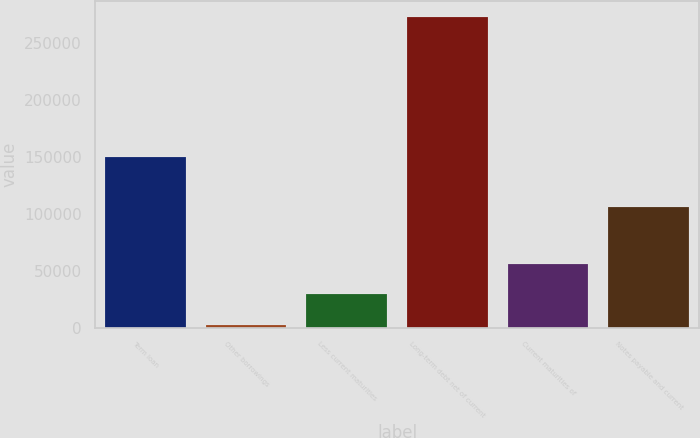Convert chart to OTSL. <chart><loc_0><loc_0><loc_500><loc_500><bar_chart><fcel>Term loan<fcel>Other borrowings<fcel>Less current maturities<fcel>Long-term debt net of current<fcel>Current maturities of<fcel>Notes payable and current<nl><fcel>150000<fcel>2244<fcel>29292.8<fcel>272732<fcel>56341.6<fcel>105963<nl></chart> 